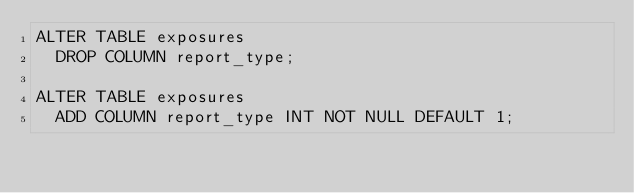<code> <loc_0><loc_0><loc_500><loc_500><_SQL_>ALTER TABLE exposures
  DROP COLUMN report_type;

ALTER TABLE exposures  
  ADD COLUMN report_type INT NOT NULL DEFAULT 1;
  </code> 